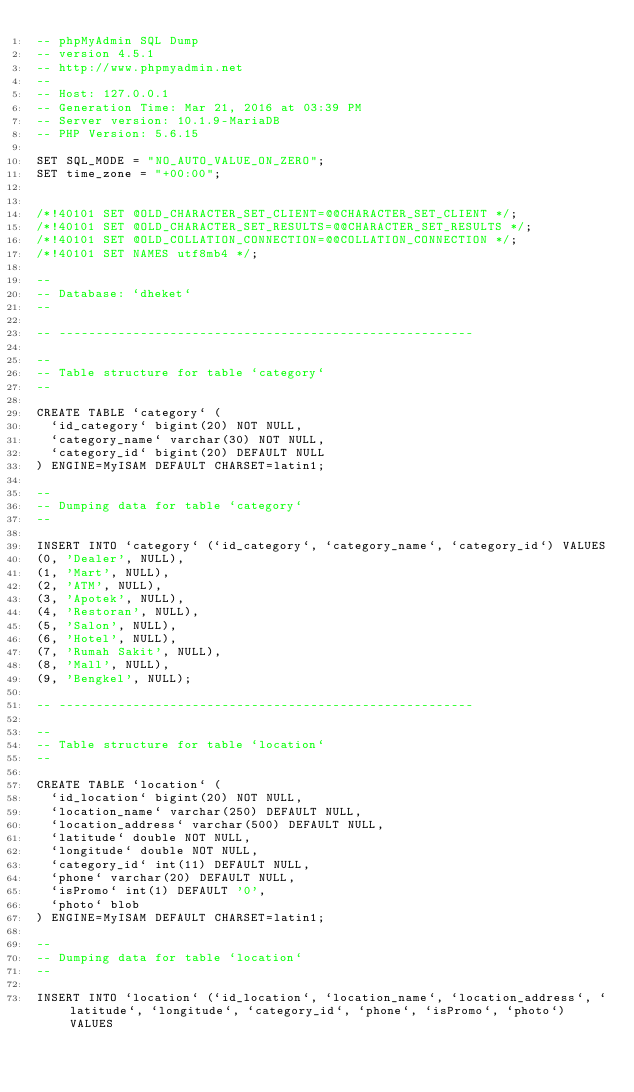Convert code to text. <code><loc_0><loc_0><loc_500><loc_500><_SQL_>-- phpMyAdmin SQL Dump
-- version 4.5.1
-- http://www.phpmyadmin.net
--
-- Host: 127.0.0.1
-- Generation Time: Mar 21, 2016 at 03:39 PM
-- Server version: 10.1.9-MariaDB
-- PHP Version: 5.6.15

SET SQL_MODE = "NO_AUTO_VALUE_ON_ZERO";
SET time_zone = "+00:00";


/*!40101 SET @OLD_CHARACTER_SET_CLIENT=@@CHARACTER_SET_CLIENT */;
/*!40101 SET @OLD_CHARACTER_SET_RESULTS=@@CHARACTER_SET_RESULTS */;
/*!40101 SET @OLD_COLLATION_CONNECTION=@@COLLATION_CONNECTION */;
/*!40101 SET NAMES utf8mb4 */;

--
-- Database: `dheket`
--

-- --------------------------------------------------------

--
-- Table structure for table `category`
--

CREATE TABLE `category` (
  `id_category` bigint(20) NOT NULL,
  `category_name` varchar(30) NOT NULL,
  `category_id` bigint(20) DEFAULT NULL
) ENGINE=MyISAM DEFAULT CHARSET=latin1;

--
-- Dumping data for table `category`
--

INSERT INTO `category` (`id_category`, `category_name`, `category_id`) VALUES
(0, 'Dealer', NULL),
(1, 'Mart', NULL),
(2, 'ATM', NULL),
(3, 'Apotek', NULL),
(4, 'Restoran', NULL),
(5, 'Salon', NULL),
(6, 'Hotel', NULL),
(7, 'Rumah Sakit', NULL),
(8, 'Mall', NULL),
(9, 'Bengkel', NULL);

-- --------------------------------------------------------

--
-- Table structure for table `location`
--

CREATE TABLE `location` (
  `id_location` bigint(20) NOT NULL,
  `location_name` varchar(250) DEFAULT NULL,
  `location_address` varchar(500) DEFAULT NULL,
  `latitude` double NOT NULL,
  `longitude` double NOT NULL,
  `category_id` int(11) DEFAULT NULL,
  `phone` varchar(20) DEFAULT NULL,
  `isPromo` int(1) DEFAULT '0',
  `photo` blob
) ENGINE=MyISAM DEFAULT CHARSET=latin1;

--
-- Dumping data for table `location`
--

INSERT INTO `location` (`id_location`, `location_name`, `location_address`, `latitude`, `longitude`, `category_id`, `phone`, `isPromo`, `photo`) VALUES</code> 